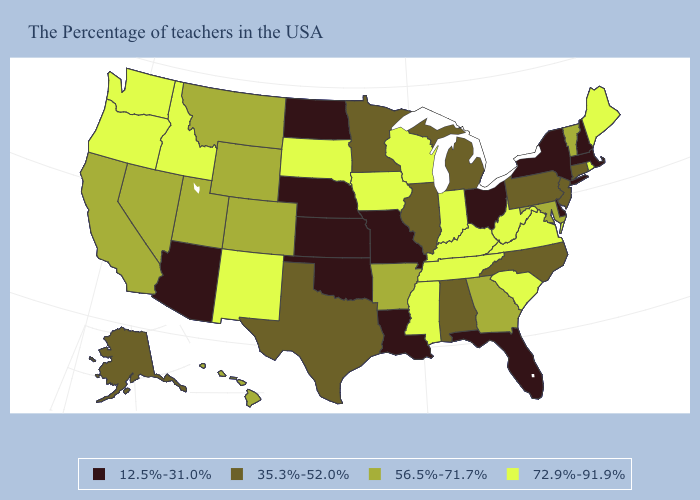What is the value of Colorado?
Write a very short answer. 56.5%-71.7%. What is the value of Washington?
Concise answer only. 72.9%-91.9%. What is the highest value in states that border Tennessee?
Short answer required. 72.9%-91.9%. Name the states that have a value in the range 35.3%-52.0%?
Answer briefly. Connecticut, New Jersey, Pennsylvania, North Carolina, Michigan, Alabama, Illinois, Minnesota, Texas, Alaska. Does Florida have a lower value than Georgia?
Answer briefly. Yes. Name the states that have a value in the range 35.3%-52.0%?
Be succinct. Connecticut, New Jersey, Pennsylvania, North Carolina, Michigan, Alabama, Illinois, Minnesota, Texas, Alaska. What is the value of Maryland?
Concise answer only. 56.5%-71.7%. Name the states that have a value in the range 35.3%-52.0%?
Quick response, please. Connecticut, New Jersey, Pennsylvania, North Carolina, Michigan, Alabama, Illinois, Minnesota, Texas, Alaska. Name the states that have a value in the range 35.3%-52.0%?
Keep it brief. Connecticut, New Jersey, Pennsylvania, North Carolina, Michigan, Alabama, Illinois, Minnesota, Texas, Alaska. What is the value of North Dakota?
Keep it brief. 12.5%-31.0%. Which states have the highest value in the USA?
Write a very short answer. Maine, Rhode Island, Virginia, South Carolina, West Virginia, Kentucky, Indiana, Tennessee, Wisconsin, Mississippi, Iowa, South Dakota, New Mexico, Idaho, Washington, Oregon. What is the highest value in states that border Washington?
Give a very brief answer. 72.9%-91.9%. What is the value of Maine?
Answer briefly. 72.9%-91.9%. What is the highest value in the USA?
Short answer required. 72.9%-91.9%. What is the highest value in the South ?
Be succinct. 72.9%-91.9%. 